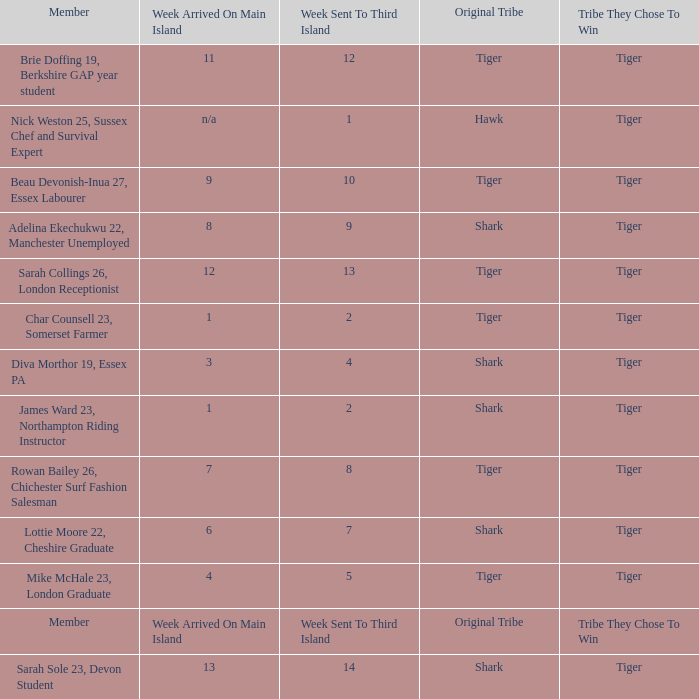What week did the member who's original tribe was shark and who was sent to the third island on week 14 arrive on the main island? 13.0. 